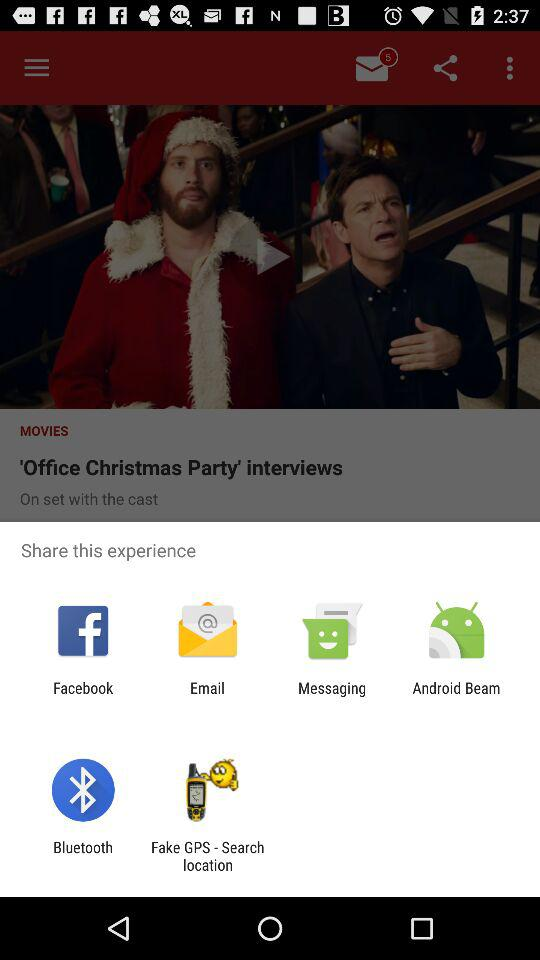What applications can be used to share the experience? The applications are "Facebook", "Email", "Messaging", "Android Beam", "Bluetooth" and "Fake GPS - Search location". 